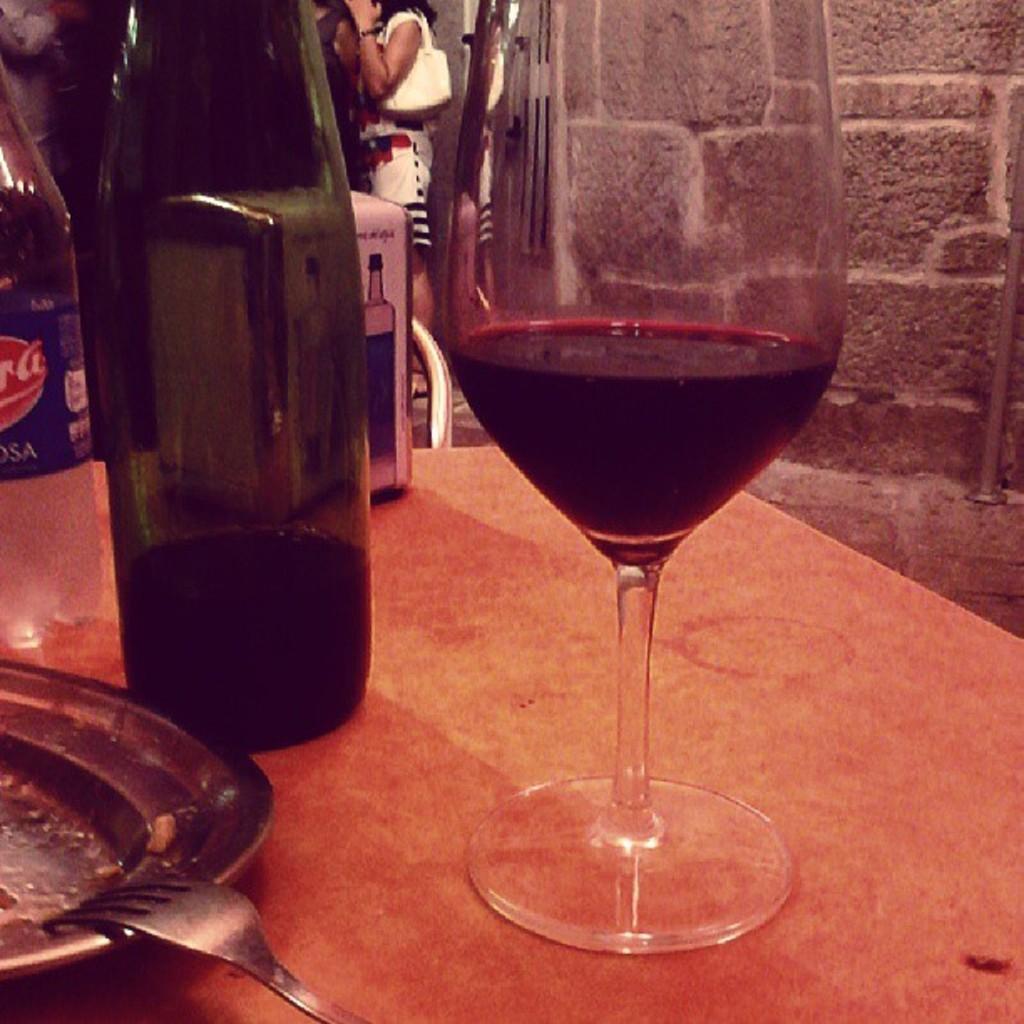Could you give a brief overview of what you see in this image? In the image we can see on the table there is a wine glass and a wine bottle and there is a plate on which there is a fork. 